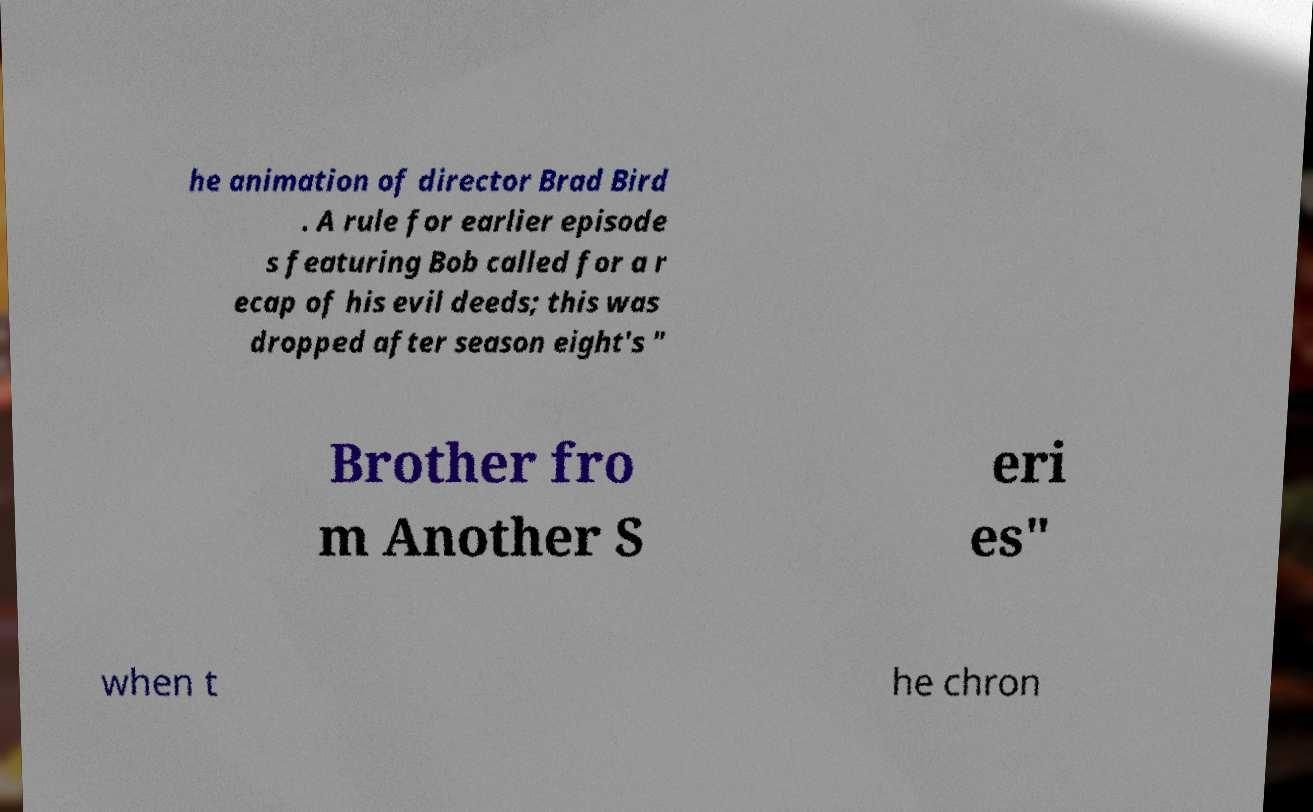Can you read and provide the text displayed in the image?This photo seems to have some interesting text. Can you extract and type it out for me? he animation of director Brad Bird . A rule for earlier episode s featuring Bob called for a r ecap of his evil deeds; this was dropped after season eight's " Brother fro m Another S eri es" when t he chron 